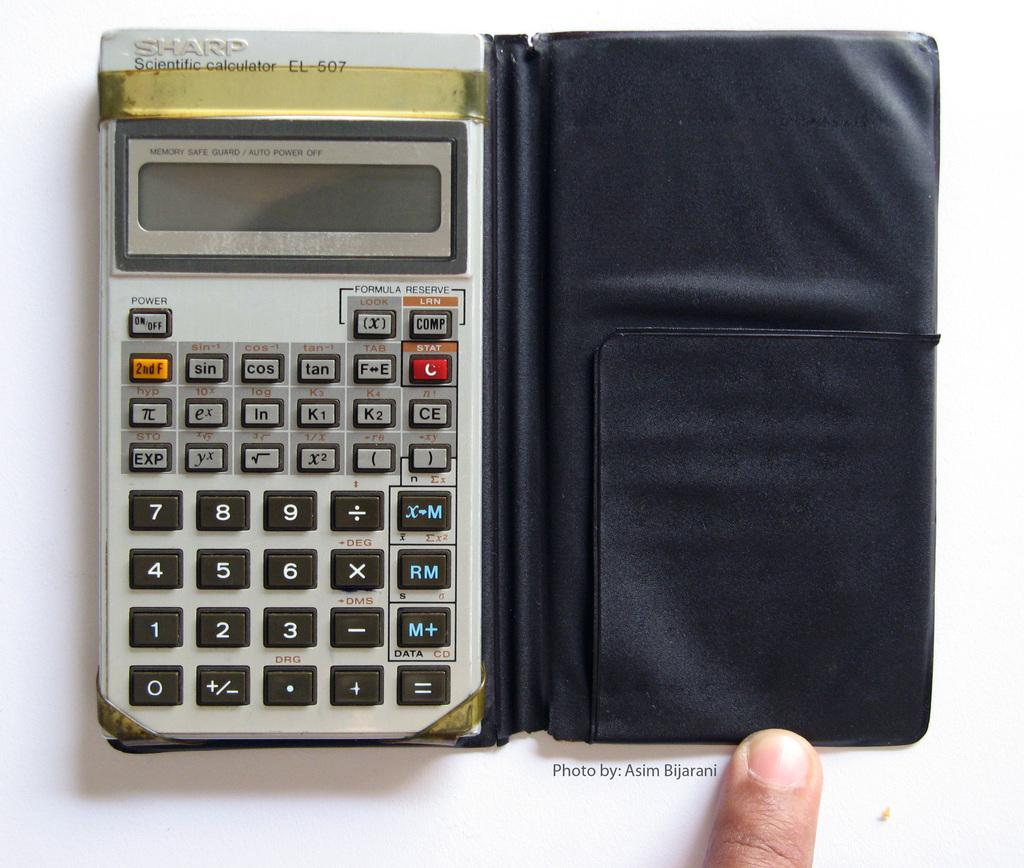<image>
Render a clear and concise summary of the photo. An old Sharp brand scientific calculator in a plastic folding case. 